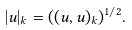<formula> <loc_0><loc_0><loc_500><loc_500>| u | _ { k } = ( ( u , u ) _ { k } ) ^ { 1 / 2 } .</formula> 